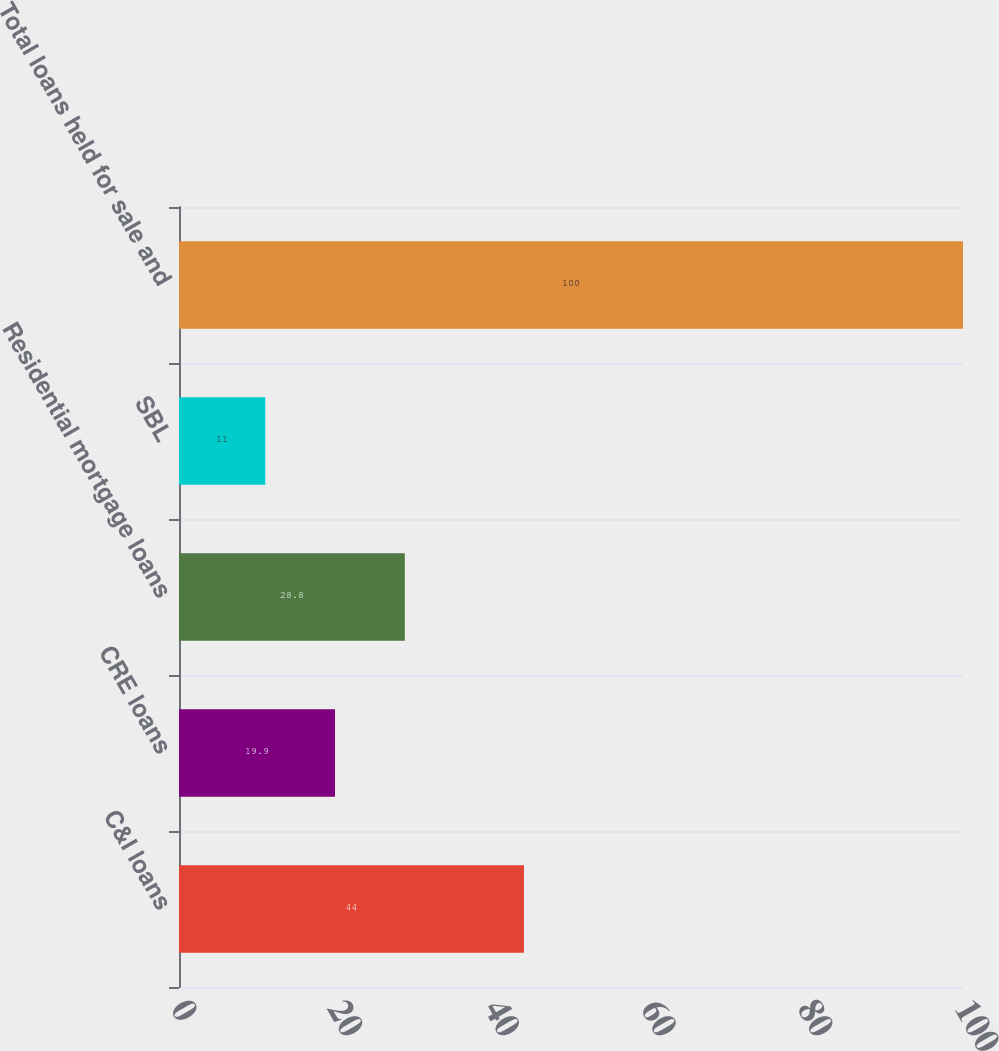Convert chart to OTSL. <chart><loc_0><loc_0><loc_500><loc_500><bar_chart><fcel>C&I loans<fcel>CRE loans<fcel>Residential mortgage loans<fcel>SBL<fcel>Total loans held for sale and<nl><fcel>44<fcel>19.9<fcel>28.8<fcel>11<fcel>100<nl></chart> 